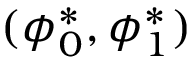<formula> <loc_0><loc_0><loc_500><loc_500>( \phi _ { 0 } ^ { * } , \phi _ { 1 } ^ { * } )</formula> 